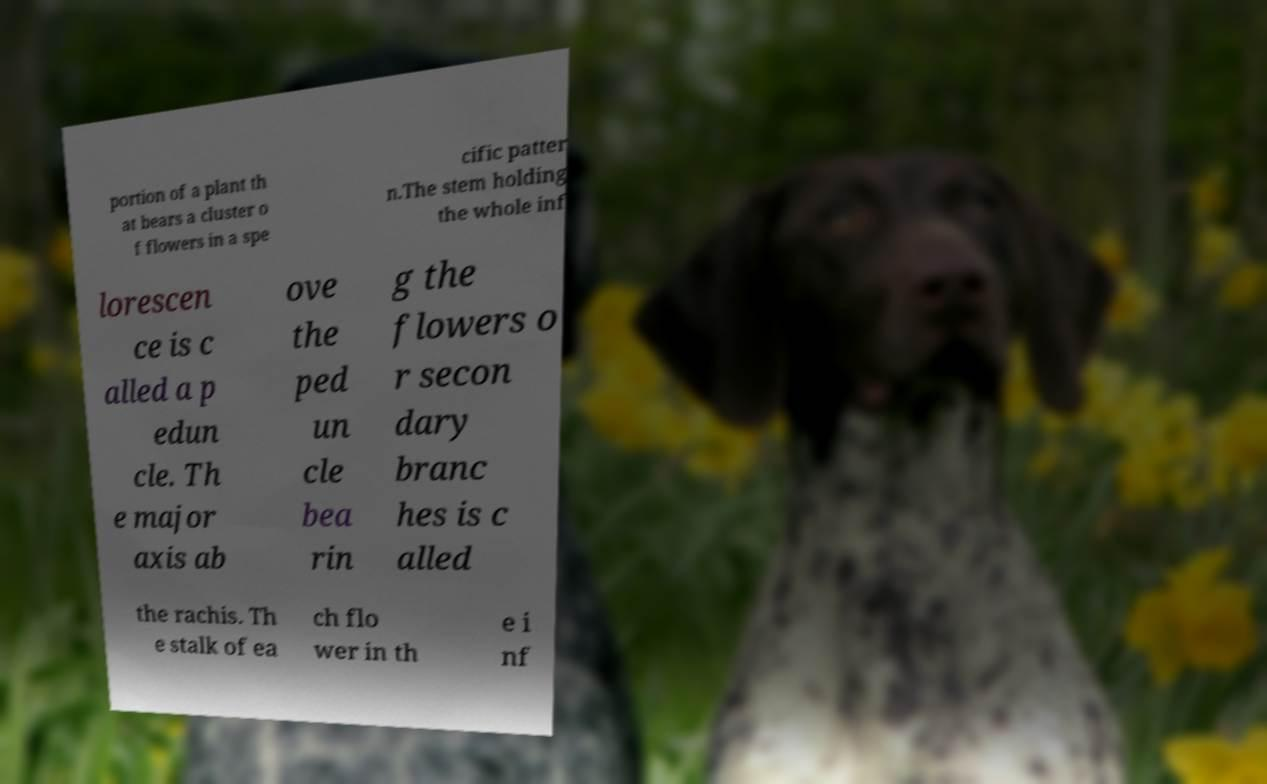Can you read and provide the text displayed in the image?This photo seems to have some interesting text. Can you extract and type it out for me? portion of a plant th at bears a cluster o f flowers in a spe cific patter n.The stem holding the whole inf lorescen ce is c alled a p edun cle. Th e major axis ab ove the ped un cle bea rin g the flowers o r secon dary branc hes is c alled the rachis. Th e stalk of ea ch flo wer in th e i nf 